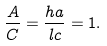<formula> <loc_0><loc_0><loc_500><loc_500>\frac { A } { C } = \frac { h a } { l c } = 1 .</formula> 